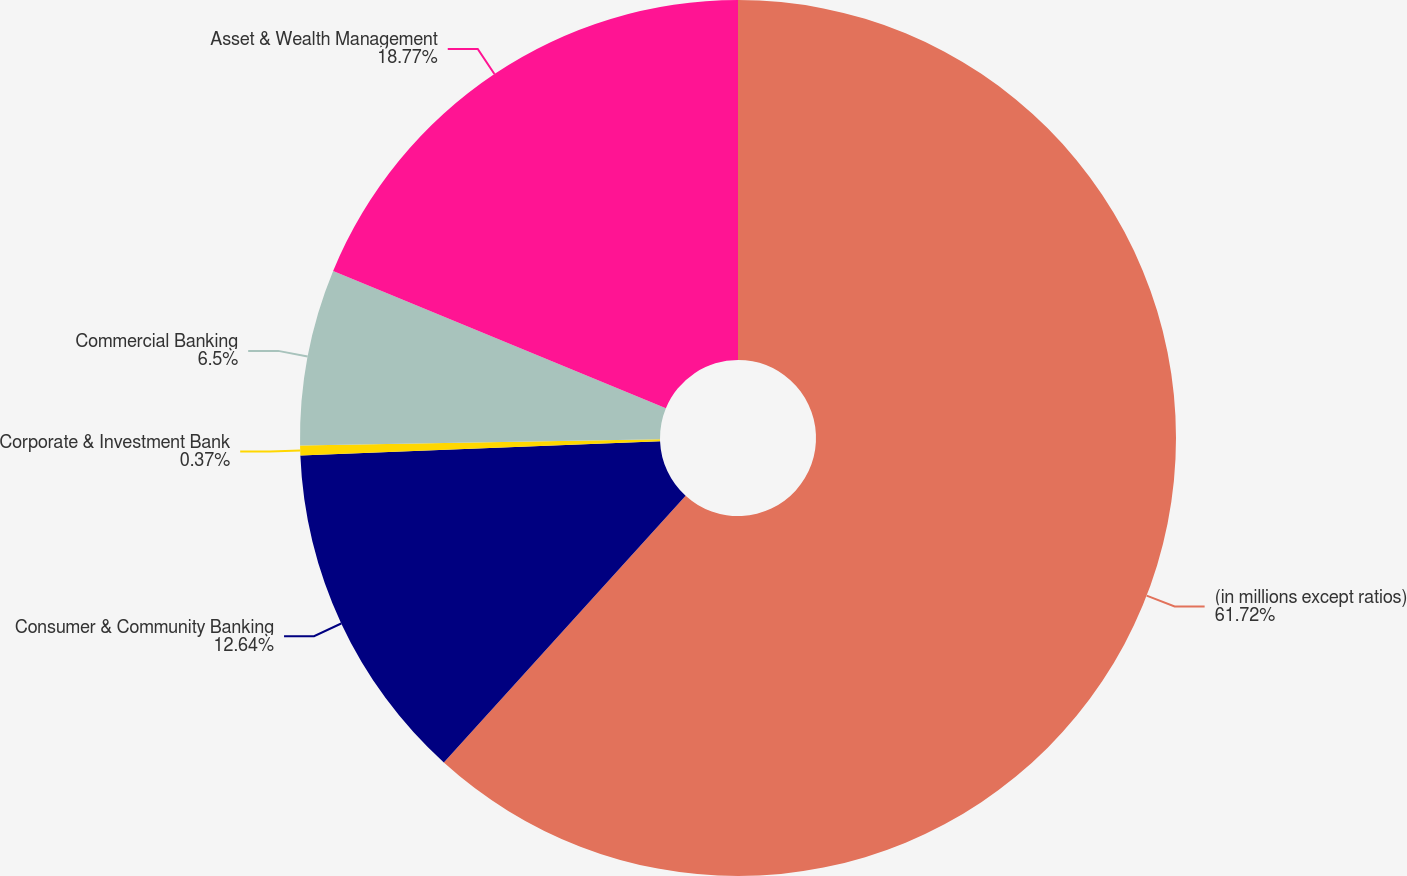<chart> <loc_0><loc_0><loc_500><loc_500><pie_chart><fcel>(in millions except ratios)<fcel>Consumer & Community Banking<fcel>Corporate & Investment Bank<fcel>Commercial Banking<fcel>Asset & Wealth Management<nl><fcel>61.72%<fcel>12.64%<fcel>0.37%<fcel>6.5%<fcel>18.77%<nl></chart> 